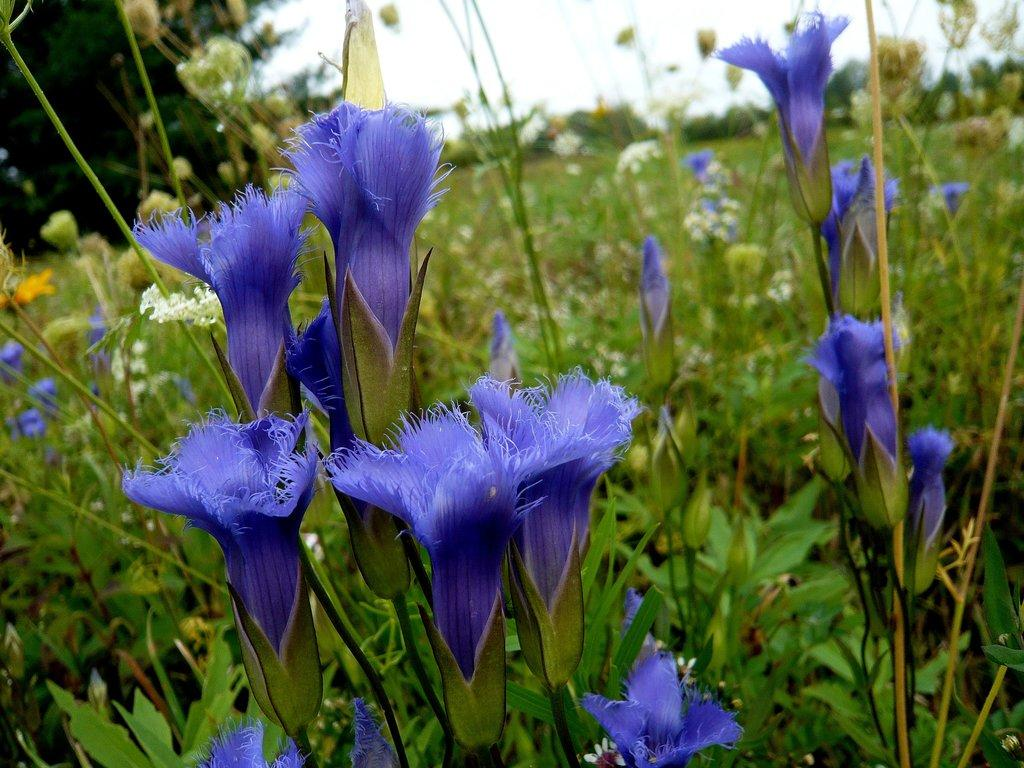What is located on the ground in the image? There is a group of flowers on the ground in the image. What can be seen in the background of the image? There is a tree and the sky visible in the background of the image. What type of book is the governor holding in the image? There is no book or governor present in the image; it features a group of flowers and a tree in the background. 